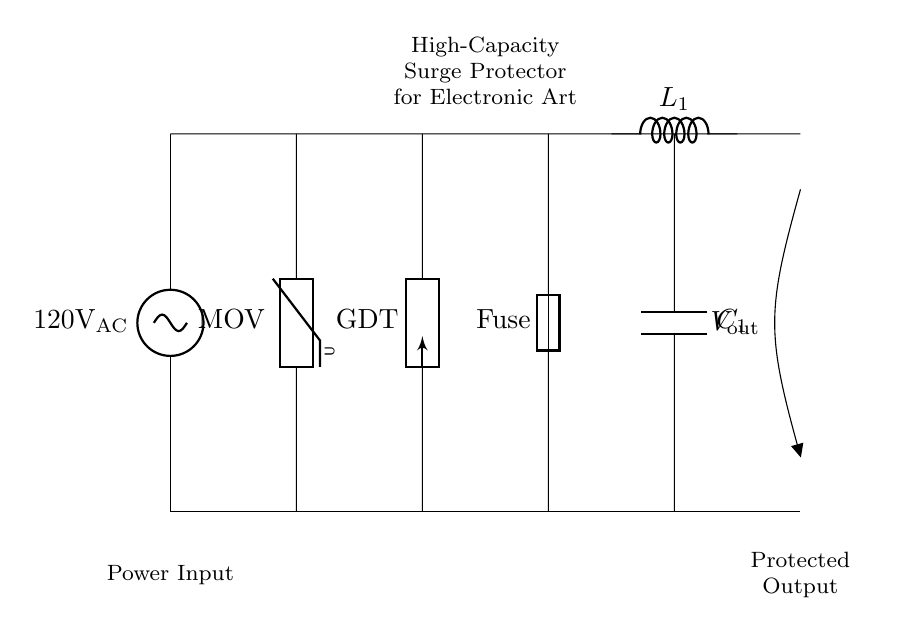What is the input voltage of this circuit? The input voltage is indicated as 120V AC, which is shown at the left side of the circuit diagram, labeled as the power input.
Answer: 120V AC What type of protective component is labeled as MOV? MOV stands for metal-oxide varistor, which is used to protect against voltage spikes. It is located in the circuit diagram between the input and the gas discharge tube.
Answer: Metal-oxide varistor What is the purpose of the fuse in this circuit? The fuse is used to protect the circuit from excessive current by breaking the connection if the current exceeds a certain limit. It is positioned in series within the circuit, ensuring overcurrent protection.
Answer: Overcurrent protection How many protection elements are present before the output? There are three protection elements: the MOV, the gas discharge tube, and the fuse. These elements collectively protect the output from surges and spikes.
Answer: Three What type of filter is implemented after the fuse? An inductor-capacitor filter is used after the fuse, consisting of an inductor labeled as L1 and a capacitor labeled as C1. This filters out unwanted noise and smooths the output voltage.
Answer: Inductor-capacitor filter What is the output labeled in the circuit diagram? The output is labeled as V out, which represents the protected output voltage that feeds into the electronic art pieces. This is located at the right side of the circuit.
Answer: V out What is the function of the gas discharge tube (GDT)? The gas discharge tube serves to divert excess voltage or surge current away from sensitive components, discharging it safely and protecting the downstream devices from damage. It is part of the surge protection system in the circuit.
Answer: Voltage diversion 